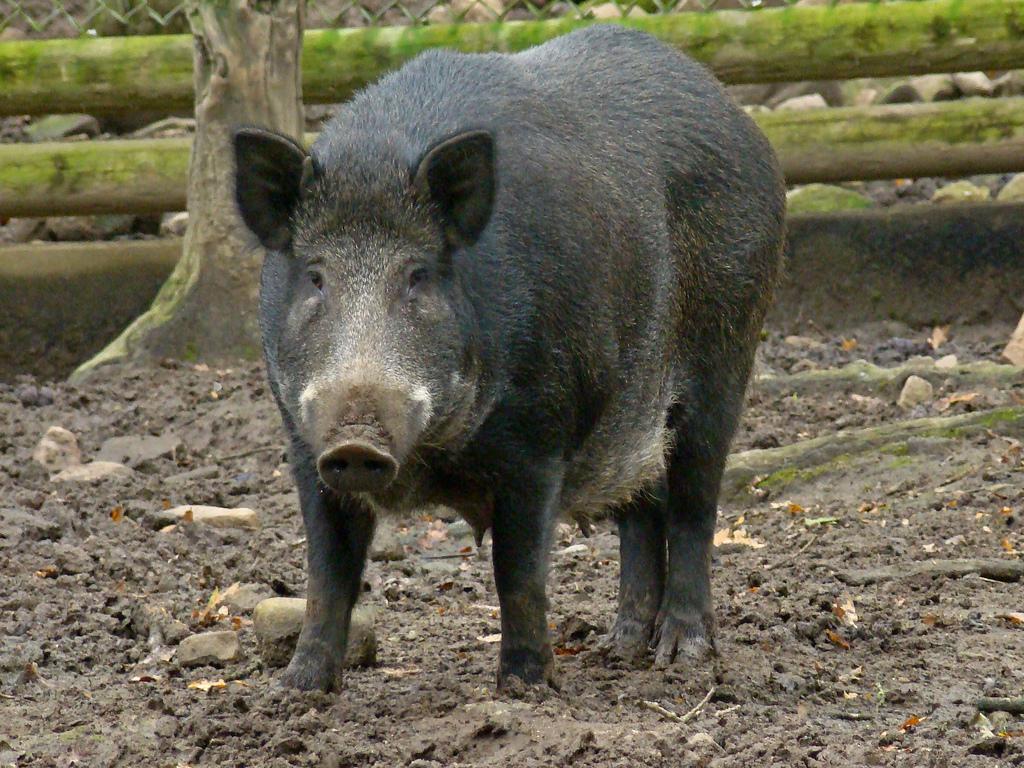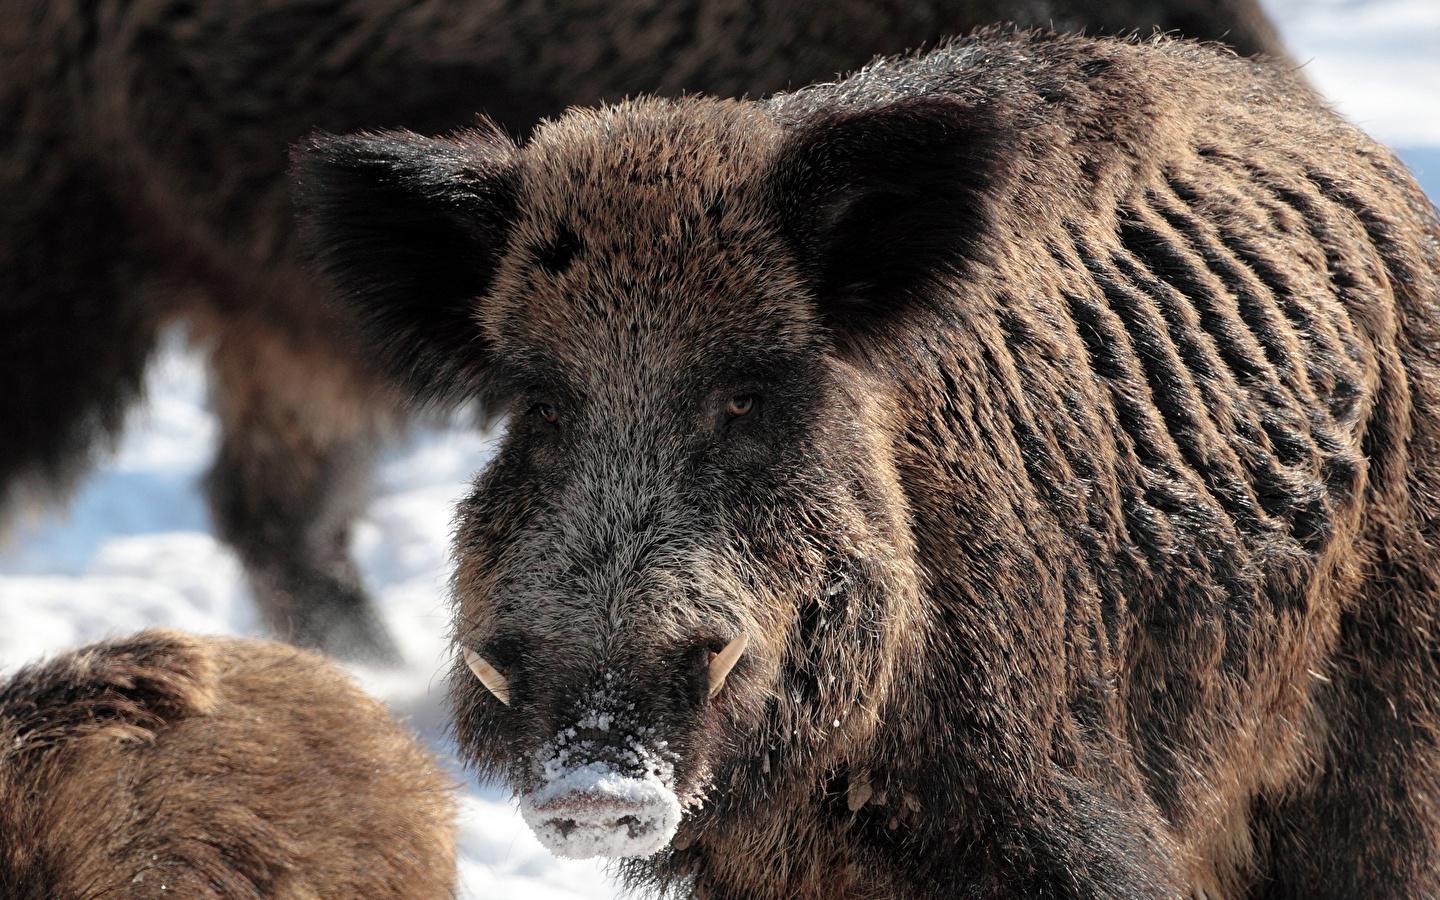The first image is the image on the left, the second image is the image on the right. For the images shown, is this caption "At least one hog walks through the snow." true? Answer yes or no. Yes. 